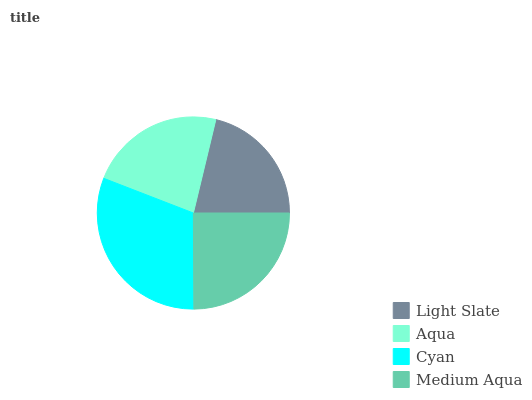Is Light Slate the minimum?
Answer yes or no. Yes. Is Cyan the maximum?
Answer yes or no. Yes. Is Aqua the minimum?
Answer yes or no. No. Is Aqua the maximum?
Answer yes or no. No. Is Aqua greater than Light Slate?
Answer yes or no. Yes. Is Light Slate less than Aqua?
Answer yes or no. Yes. Is Light Slate greater than Aqua?
Answer yes or no. No. Is Aqua less than Light Slate?
Answer yes or no. No. Is Medium Aqua the high median?
Answer yes or no. Yes. Is Aqua the low median?
Answer yes or no. Yes. Is Light Slate the high median?
Answer yes or no. No. Is Light Slate the low median?
Answer yes or no. No. 